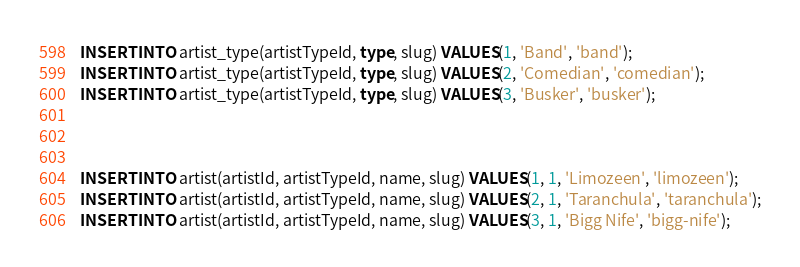<code> <loc_0><loc_0><loc_500><loc_500><_SQL_>INSERT INTO artist_type(artistTypeId, type, slug) VALUES(1, 'Band', 'band');
INSERT INTO artist_type(artistTypeId, type, slug) VALUES(2, 'Comedian', 'comedian');
INSERT INTO artist_type(artistTypeId, type, slug) VALUES(3, 'Busker', 'busker');



INSERT INTO artist(artistId, artistTypeId, name, slug) VALUES(1, 1, 'Limozeen', 'limozeen');
INSERT INTO artist(artistId, artistTypeId, name, slug) VALUES(2, 1, 'Taranchula', 'taranchula');
INSERT INTO artist(artistId, artistTypeId, name, slug) VALUES(3, 1, 'Bigg Nife', 'bigg-nife');</code> 